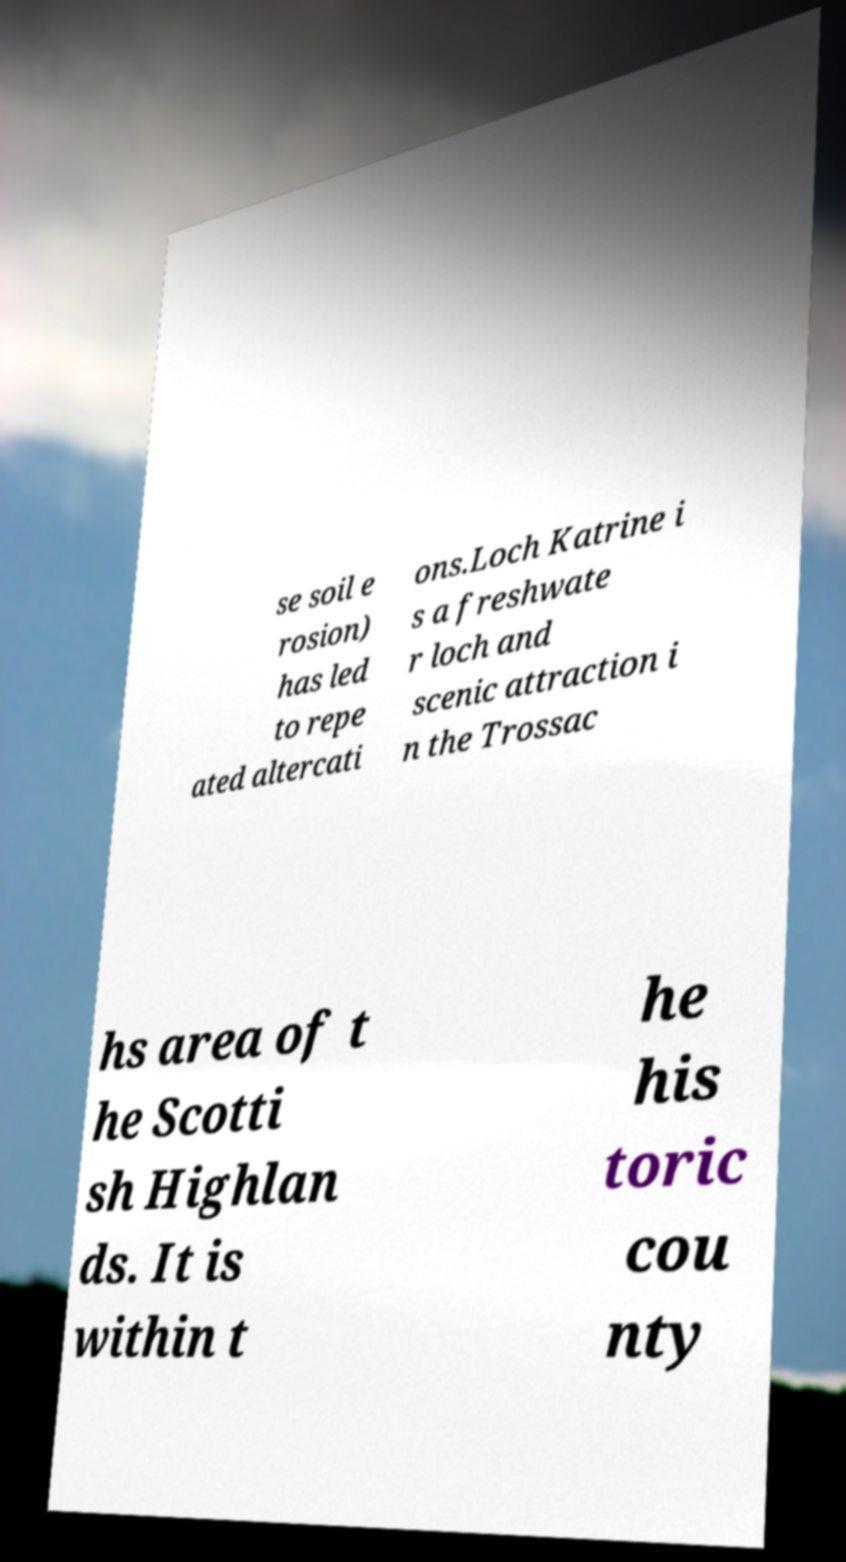There's text embedded in this image that I need extracted. Can you transcribe it verbatim? se soil e rosion) has led to repe ated altercati ons.Loch Katrine i s a freshwate r loch and scenic attraction i n the Trossac hs area of t he Scotti sh Highlan ds. It is within t he his toric cou nty 